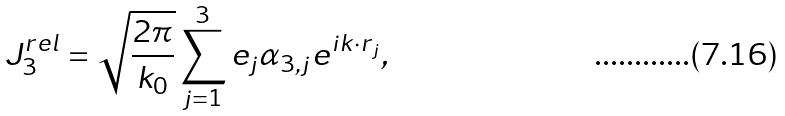Convert formula to latex. <formula><loc_0><loc_0><loc_500><loc_500>J _ { 3 } ^ { r e l } = \sqrt { \frac { 2 \pi } { k _ { 0 } } } \sum _ { j = 1 } ^ { 3 } e _ { j } { \alpha _ { 3 , j } } e ^ { i { k \cdot r } _ { j } } ,</formula> 